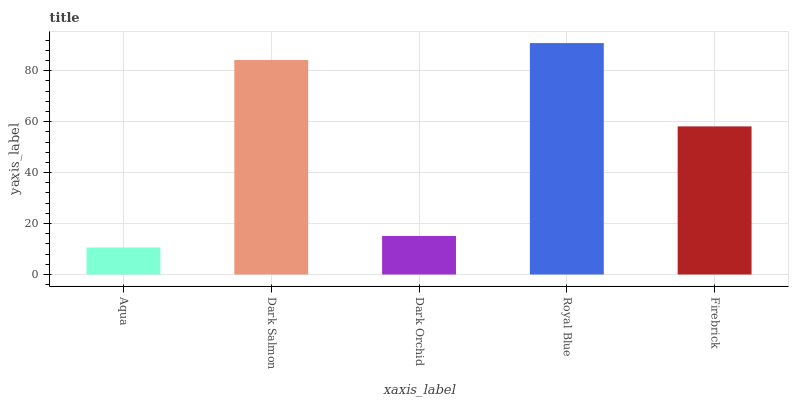Is Aqua the minimum?
Answer yes or no. Yes. Is Royal Blue the maximum?
Answer yes or no. Yes. Is Dark Salmon the minimum?
Answer yes or no. No. Is Dark Salmon the maximum?
Answer yes or no. No. Is Dark Salmon greater than Aqua?
Answer yes or no. Yes. Is Aqua less than Dark Salmon?
Answer yes or no. Yes. Is Aqua greater than Dark Salmon?
Answer yes or no. No. Is Dark Salmon less than Aqua?
Answer yes or no. No. Is Firebrick the high median?
Answer yes or no. Yes. Is Firebrick the low median?
Answer yes or no. Yes. Is Dark Salmon the high median?
Answer yes or no. No. Is Aqua the low median?
Answer yes or no. No. 